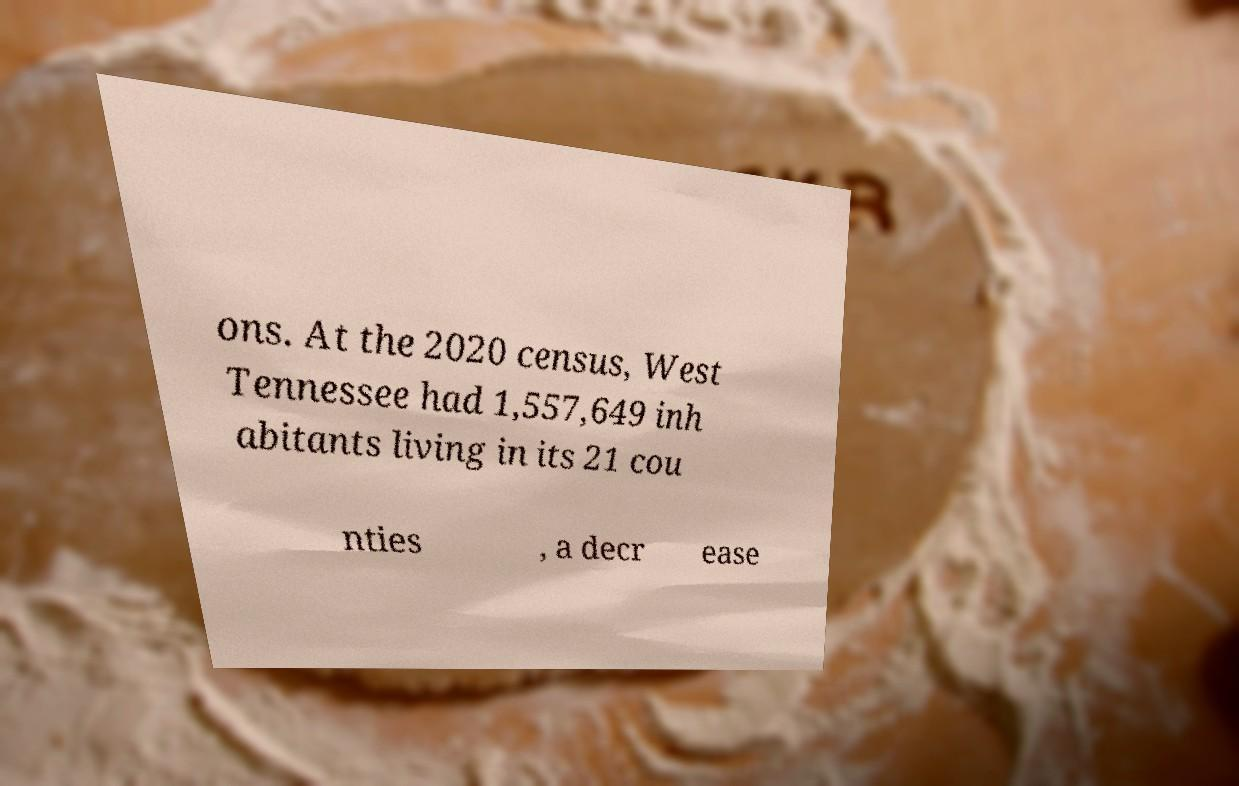Can you read and provide the text displayed in the image?This photo seems to have some interesting text. Can you extract and type it out for me? ons. At the 2020 census, West Tennessee had 1,557,649 inh abitants living in its 21 cou nties , a decr ease 